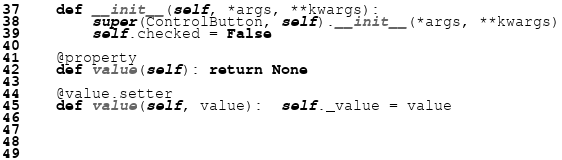<code> <loc_0><loc_0><loc_500><loc_500><_Python_>
    def __init__(self, *args, **kwargs):
        super(ControlButton, self).__init__(*args, **kwargs)
        self.checked = False

    @property
    def value(self): return None

    @value.setter
    def value(self, value):  self._value = value
        


    </code> 